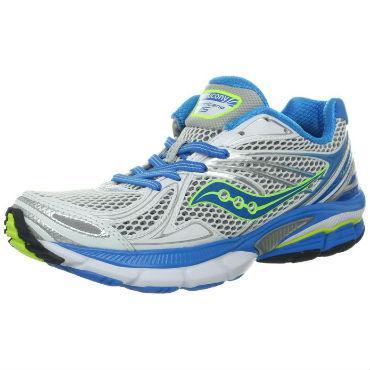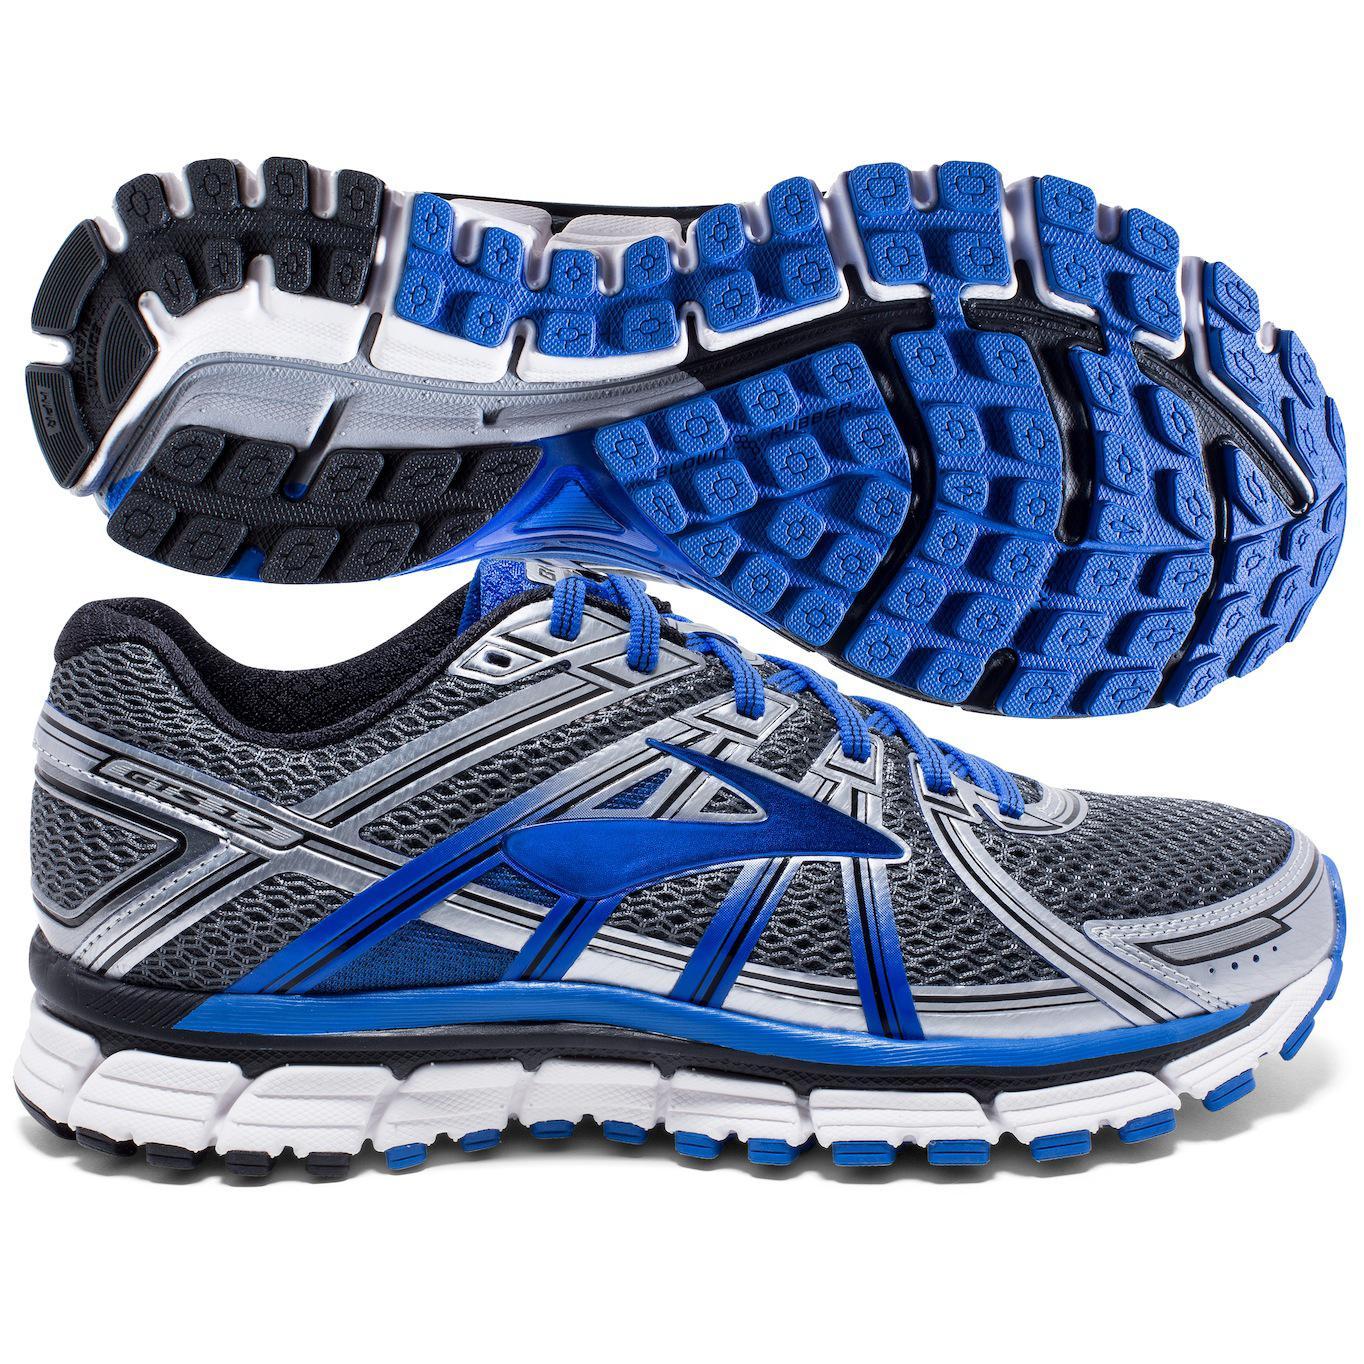The first image is the image on the left, the second image is the image on the right. Considering the images on both sides, is "All shoes pictured are facing rightward." valid? Answer yes or no. No. The first image is the image on the left, the second image is the image on the right. Considering the images on both sides, is "There is at least one sneaker that is mainly gray and has blue laces." valid? Answer yes or no. Yes. 